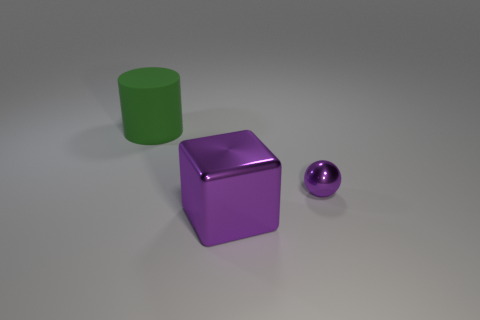Is there any other thing that has the same size as the sphere?
Give a very brief answer. No. What is the material of the tiny object that is the same color as the metal cube?
Your response must be concise. Metal. Are there any objects of the same color as the tiny sphere?
Make the answer very short. Yes. How many other things are made of the same material as the purple sphere?
Offer a very short reply. 1. What shape is the object to the left of the large object in front of the green cylinder?
Offer a very short reply. Cylinder. There is a purple thing that is in front of the tiny thing; how big is it?
Make the answer very short. Large. Is the material of the big block the same as the tiny purple object?
Your response must be concise. Yes. What shape is the thing that is the same material as the purple cube?
Provide a short and direct response. Sphere. Is there anything else that has the same color as the large matte object?
Offer a terse response. No. What color is the large object that is in front of the big matte thing?
Your answer should be very brief. Purple. 